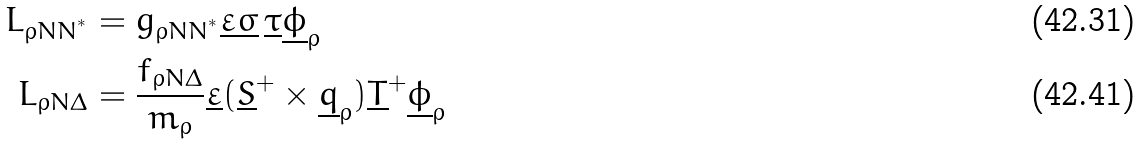<formula> <loc_0><loc_0><loc_500><loc_500>L _ { \rho N N ^ { ^ { * } } } & = g _ { \rho N N ^ { ^ { * } } } \underline { \varepsilon } \underline { \sigma } \, \underline { \tau } \underline { \phi } _ { \rho } \\ L _ { \rho N \Delta } & = \frac { f _ { \rho N \Delta } } { m _ { \rho } } \underline { \varepsilon } ( \underline { S } ^ { + } \times \underline { q } _ { \rho } ) \underline { T } ^ { + } \underline { \phi } _ { \rho }</formula> 